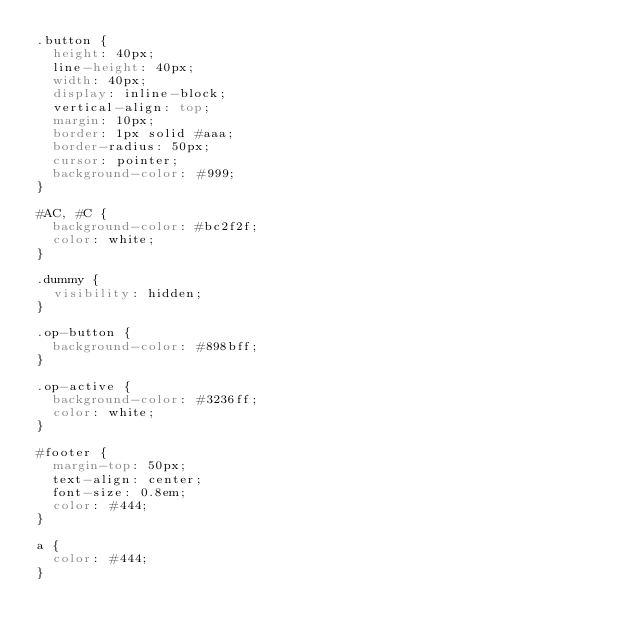<code> <loc_0><loc_0><loc_500><loc_500><_CSS_>.button {
  height: 40px;
  line-height: 40px;
  width: 40px;
  display: inline-block;
  vertical-align: top;
  margin: 10px;
  border: 1px solid #aaa;
  border-radius: 50px;
  cursor: pointer;
  background-color: #999;
}

#AC, #C {
  background-color: #bc2f2f;
  color: white;
}

.dummy {
  visibility: hidden;
}

.op-button {
  background-color: #898bff;
}

.op-active {
  background-color: #3236ff;
  color: white;
}

#footer {
  margin-top: 50px;
  text-align: center;
  font-size: 0.8em;
  color: #444;
}

a {
  color: #444;
}</code> 